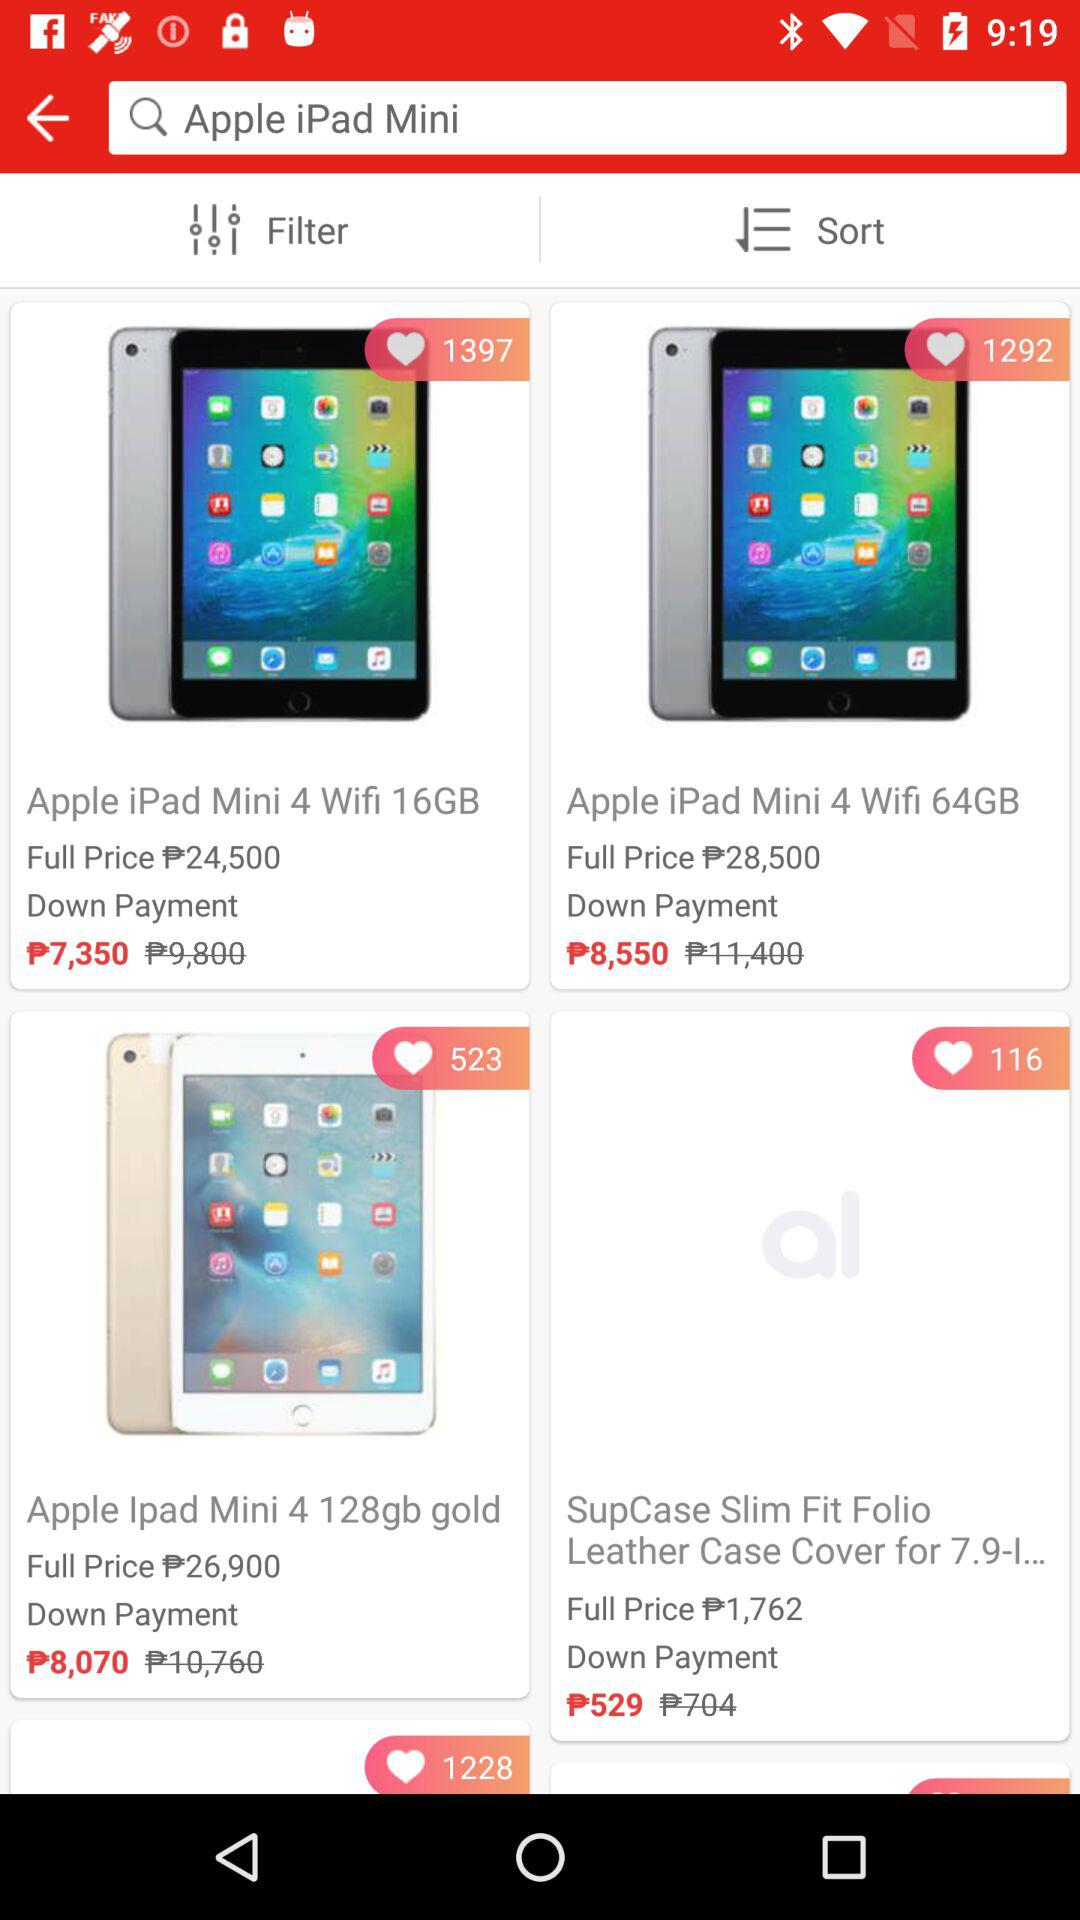How many likes has the "Apple iPad Mini 4 Wifi 64GB" received? The "Apple iPad Mini 4 Wifi 64GB" has received 1292 likes. 